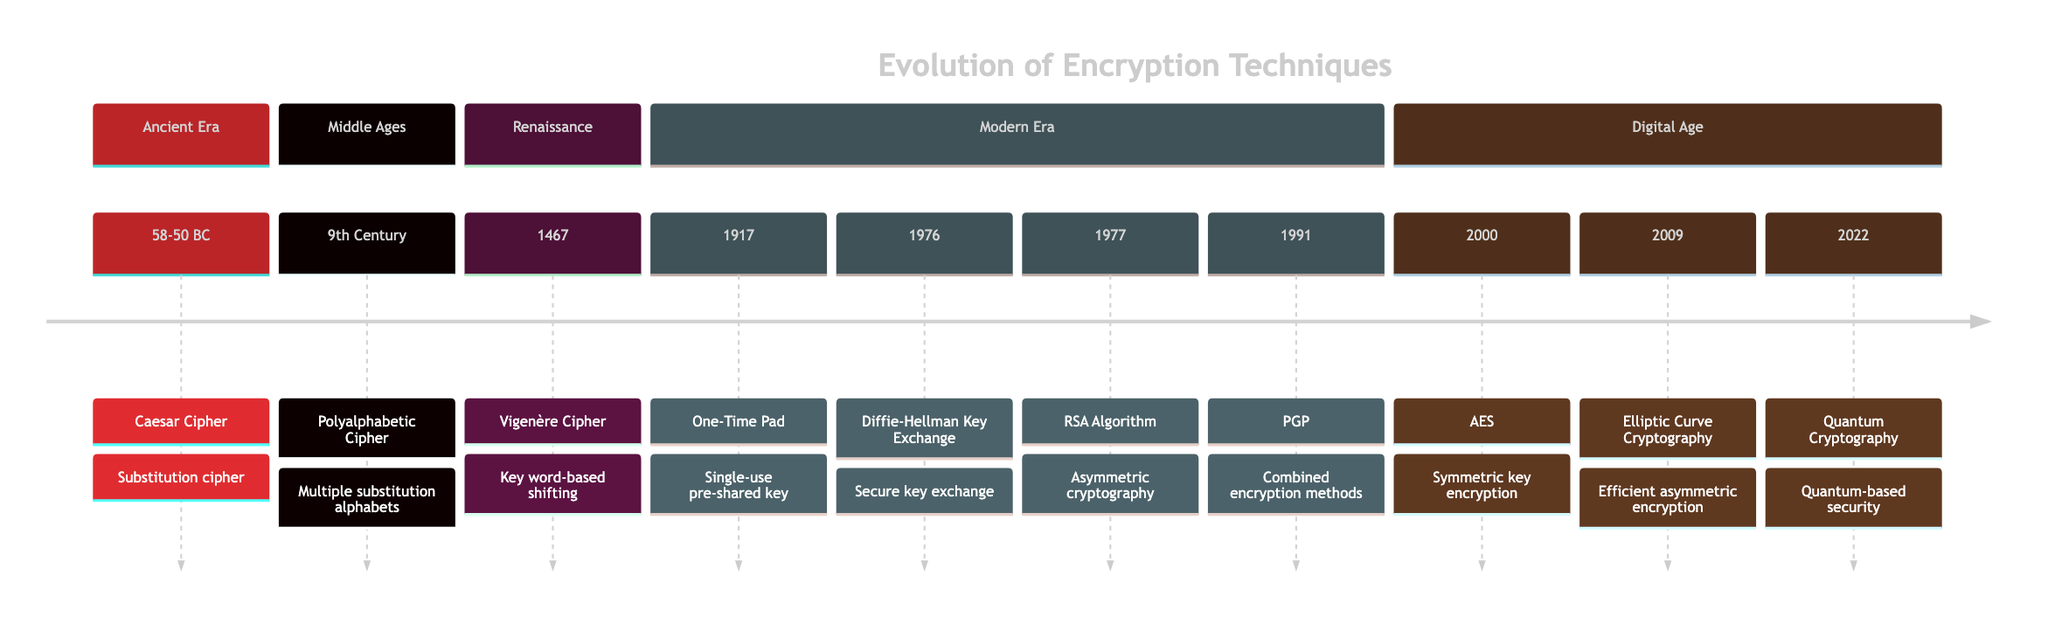What is the earliest encryption technique listed? The timeline starts with the "Caesar Cipher," which is the first technique mentioned within the Ancient Era section, dated 58-50 BC.
Answer: Caesar Cipher Which technique was developed in the 9th Century? The timeline indicates that the "Polyalphabetic Cipher" was created during the 9th Century, making it the second entry following the Caesar Cipher.
Answer: Polyalphabetic Cipher What year saw the introduction of the AES? The diagram specifically marks the year 2000 when "AES" (Advanced Encryption Standard) was adopted, indicating it as a significant milestone in the Digital Age section.
Answer: 2000 How many techniques are introduced before the year 1900? The diagram lists four techniques (Caesar Cipher in 58-50 BC, Polyalphabetic Cipher in the 9th Century, Vigenère Cipher in 1467, and One-Time Pad in 1917) before reaching the year 1900.
Answer: 4 Which two techniques were developed in the same year? The diagram does not reveal any two techniques developed in the same year; hence examining all years listed confirms that no overlaps exist.
Answer: None What is the last technique mentioned in the timeline? The timeline concludes with "Quantum Cryptography" in the year 2022, indicating it as the most recent development in encryption techniques.
Answer: Quantum Cryptography Which cipher uses a key word to perform shifts? According to the timeline, the "Vigenère Cipher," invented in 1467, employs a key word to shift letters along rows, which is part of its defining characteristic.
Answer: Vigenère Cipher What encryption method focuses on secure key exchange? The "Diffie-Hellman Key Exchange," introduced in 1976, is explicitly noted as a technique focused on secure cryptographic key exchange over public channels.
Answer: Diffie-Hellman Key Exchange What encryption technique is promoted by the NSA? The diagram highlights "Elliptic Curve Cryptography," introduced in 2009, as being promoted by the NSA for its security efficiency and performance benefits.
Answer: Elliptic Curve Cryptography 